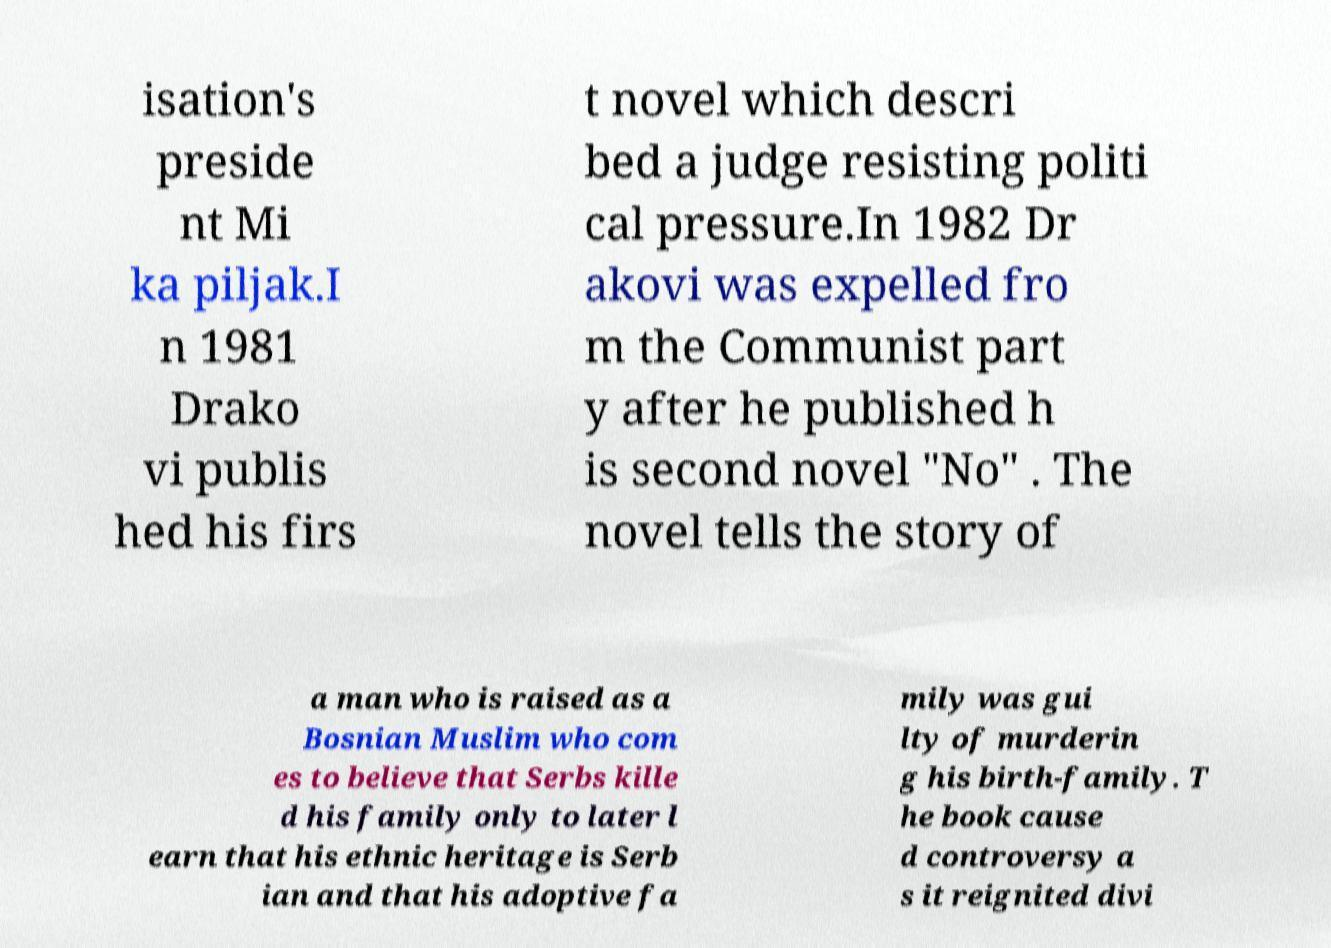Can you accurately transcribe the text from the provided image for me? isation's preside nt Mi ka piljak.I n 1981 Drako vi publis hed his firs t novel which descri bed a judge resisting politi cal pressure.In 1982 Dr akovi was expelled fro m the Communist part y after he published h is second novel "No" . The novel tells the story of a man who is raised as a Bosnian Muslim who com es to believe that Serbs kille d his family only to later l earn that his ethnic heritage is Serb ian and that his adoptive fa mily was gui lty of murderin g his birth-family. T he book cause d controversy a s it reignited divi 